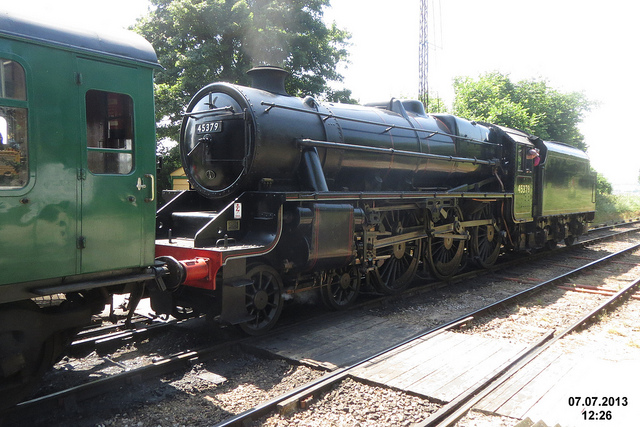Who invented this vehicle?
A. richard trevithick
B. orville wright
C. jeff goldblum
D. bill nye
Answer with the option's letter from the given choices directly. A 